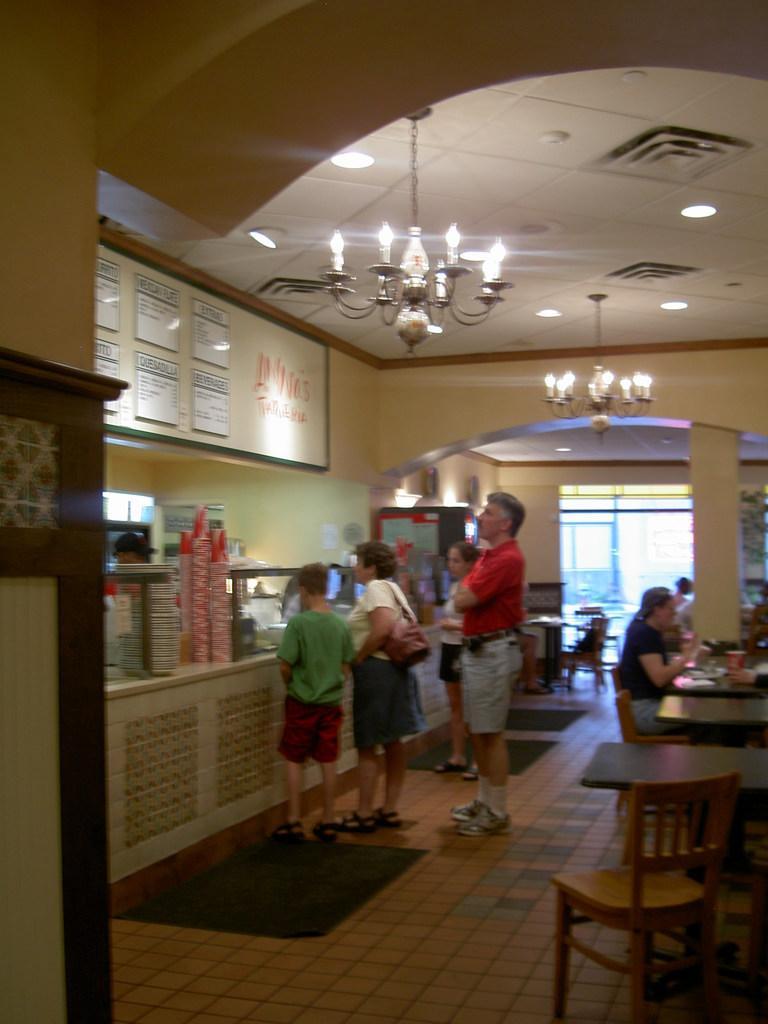How would you summarize this image in a sentence or two? In this image I can see people were few of them are sitting and rest all are standing. I can also see few chairs, tables and number of glasses. 